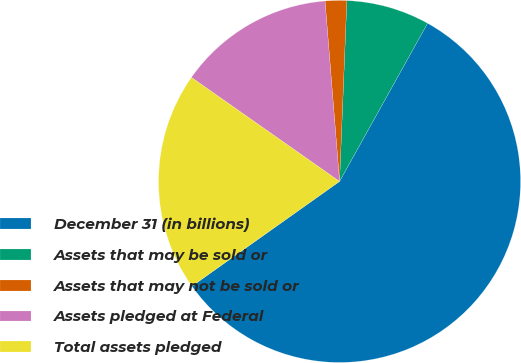<chart> <loc_0><loc_0><loc_500><loc_500><pie_chart><fcel>December 31 (in billions)<fcel>Assets that may be sold or<fcel>Assets that may not be sold or<fcel>Assets pledged at Federal<fcel>Total assets pledged<nl><fcel>57.1%<fcel>7.44%<fcel>1.92%<fcel>13.98%<fcel>19.57%<nl></chart> 